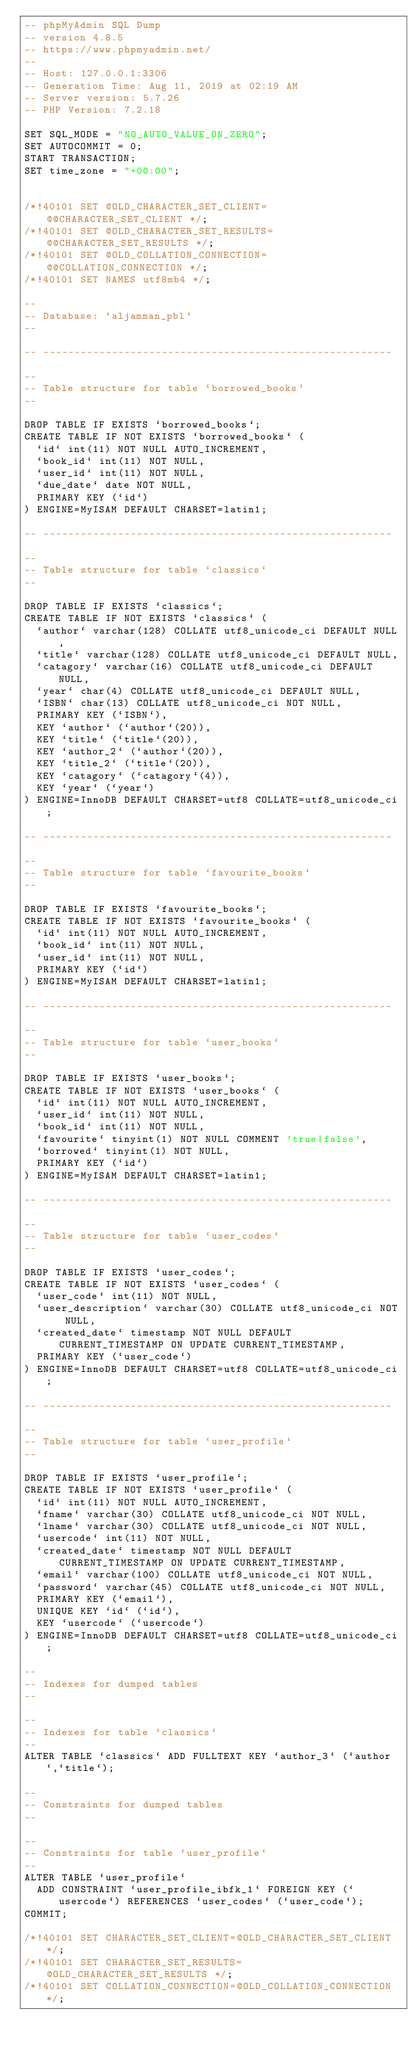Convert code to text. <code><loc_0><loc_0><loc_500><loc_500><_SQL_>-- phpMyAdmin SQL Dump
-- version 4.8.5
-- https://www.phpmyadmin.net/
--
-- Host: 127.0.0.1:3306
-- Generation Time: Aug 11, 2019 at 02:19 AM
-- Server version: 5.7.26
-- PHP Version: 7.2.18

SET SQL_MODE = "NO_AUTO_VALUE_ON_ZERO";
SET AUTOCOMMIT = 0;
START TRANSACTION;
SET time_zone = "+00:00";


/*!40101 SET @OLD_CHARACTER_SET_CLIENT=@@CHARACTER_SET_CLIENT */;
/*!40101 SET @OLD_CHARACTER_SET_RESULTS=@@CHARACTER_SET_RESULTS */;
/*!40101 SET @OLD_COLLATION_CONNECTION=@@COLLATION_CONNECTION */;
/*!40101 SET NAMES utf8mb4 */;

--
-- Database: `aljamman_pbl`
--

-- --------------------------------------------------------

--
-- Table structure for table `borrowed_books`
--

DROP TABLE IF EXISTS `borrowed_books`;
CREATE TABLE IF NOT EXISTS `borrowed_books` (
  `id` int(11) NOT NULL AUTO_INCREMENT,
  `book_id` int(11) NOT NULL,
  `user_id` int(11) NOT NULL,
  `due_date` date NOT NULL,
  PRIMARY KEY (`id`)
) ENGINE=MyISAM DEFAULT CHARSET=latin1;

-- --------------------------------------------------------

--
-- Table structure for table `classics`
--

DROP TABLE IF EXISTS `classics`;
CREATE TABLE IF NOT EXISTS `classics` (
  `author` varchar(128) COLLATE utf8_unicode_ci DEFAULT NULL,
  `title` varchar(128) COLLATE utf8_unicode_ci DEFAULT NULL,
  `catagory` varchar(16) COLLATE utf8_unicode_ci DEFAULT NULL,
  `year` char(4) COLLATE utf8_unicode_ci DEFAULT NULL,
  `ISBN` char(13) COLLATE utf8_unicode_ci NOT NULL,
  PRIMARY KEY (`ISBN`),
  KEY `author` (`author`(20)),
  KEY `title` (`title`(20)),
  KEY `author_2` (`author`(20)),
  KEY `title_2` (`title`(20)),
  KEY `catagory` (`catagory`(4)),
  KEY `year` (`year`)
) ENGINE=InnoDB DEFAULT CHARSET=utf8 COLLATE=utf8_unicode_ci;

-- --------------------------------------------------------

--
-- Table structure for table `favourite_books`
--

DROP TABLE IF EXISTS `favourite_books`;
CREATE TABLE IF NOT EXISTS `favourite_books` (
  `id` int(11) NOT NULL AUTO_INCREMENT,
  `book_id` int(11) NOT NULL,
  `user_id` int(11) NOT NULL,
  PRIMARY KEY (`id`)
) ENGINE=MyISAM DEFAULT CHARSET=latin1;

-- --------------------------------------------------------

--
-- Table structure for table `user_books`
--

DROP TABLE IF EXISTS `user_books`;
CREATE TABLE IF NOT EXISTS `user_books` (
  `id` int(11) NOT NULL AUTO_INCREMENT,
  `user_id` int(11) NOT NULL,
  `book_id` int(11) NOT NULL,
  `favourite` tinyint(1) NOT NULL COMMENT 'true|false',
  `borrowed` tinyint(1) NOT NULL,
  PRIMARY KEY (`id`)
) ENGINE=MyISAM DEFAULT CHARSET=latin1;

-- --------------------------------------------------------

--
-- Table structure for table `user_codes`
--

DROP TABLE IF EXISTS `user_codes`;
CREATE TABLE IF NOT EXISTS `user_codes` (
  `user_code` int(11) NOT NULL,
  `user_description` varchar(30) COLLATE utf8_unicode_ci NOT NULL,
  `created_date` timestamp NOT NULL DEFAULT CURRENT_TIMESTAMP ON UPDATE CURRENT_TIMESTAMP,
  PRIMARY KEY (`user_code`)
) ENGINE=InnoDB DEFAULT CHARSET=utf8 COLLATE=utf8_unicode_ci;

-- --------------------------------------------------------

--
-- Table structure for table `user_profile`
--

DROP TABLE IF EXISTS `user_profile`;
CREATE TABLE IF NOT EXISTS `user_profile` (
  `id` int(11) NOT NULL AUTO_INCREMENT,
  `fname` varchar(30) COLLATE utf8_unicode_ci NOT NULL,
  `lname` varchar(30) COLLATE utf8_unicode_ci NOT NULL,
  `usercode` int(11) NOT NULL,
  `created_date` timestamp NOT NULL DEFAULT CURRENT_TIMESTAMP ON UPDATE CURRENT_TIMESTAMP,
  `email` varchar(100) COLLATE utf8_unicode_ci NOT NULL,
  `password` varchar(45) COLLATE utf8_unicode_ci NOT NULL,
  PRIMARY KEY (`email`),
  UNIQUE KEY `id` (`id`),
  KEY `usercode` (`usercode`)
) ENGINE=InnoDB DEFAULT CHARSET=utf8 COLLATE=utf8_unicode_ci;

--
-- Indexes for dumped tables
--

--
-- Indexes for table `classics`
--
ALTER TABLE `classics` ADD FULLTEXT KEY `author_3` (`author`,`title`);

--
-- Constraints for dumped tables
--

--
-- Constraints for table `user_profile`
--
ALTER TABLE `user_profile`
  ADD CONSTRAINT `user_profile_ibfk_1` FOREIGN KEY (`usercode`) REFERENCES `user_codes` (`user_code`);
COMMIT;

/*!40101 SET CHARACTER_SET_CLIENT=@OLD_CHARACTER_SET_CLIENT */;
/*!40101 SET CHARACTER_SET_RESULTS=@OLD_CHARACTER_SET_RESULTS */;
/*!40101 SET COLLATION_CONNECTION=@OLD_COLLATION_CONNECTION */;
</code> 